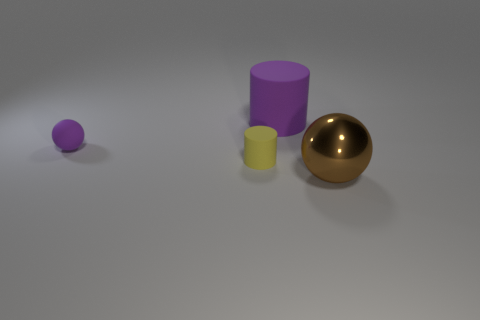Subtract 1 balls. How many balls are left? 1 Add 3 brown objects. How many objects exist? 7 Subtract 0 gray cylinders. How many objects are left? 4 Subtract all blue spheres. Subtract all red cylinders. How many spheres are left? 2 Subtract all blue cubes. How many red cylinders are left? 0 Subtract all tiny rubber spheres. Subtract all small yellow cylinders. How many objects are left? 2 Add 3 matte balls. How many matte balls are left? 4 Add 4 tiny purple spheres. How many tiny purple spheres exist? 5 